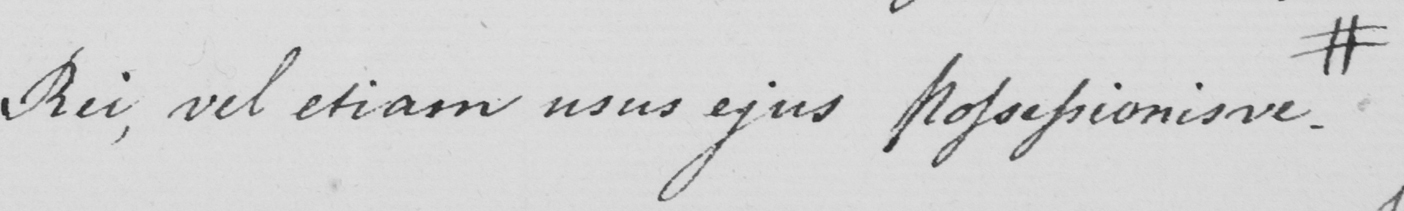Can you read and transcribe this handwriting? Rei , vel etiam usus ejus Possessionisve . # 